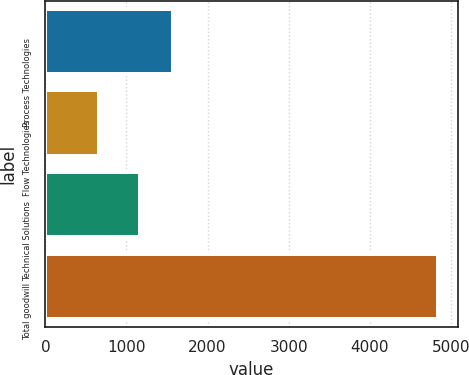<chart> <loc_0><loc_0><loc_500><loc_500><bar_chart><fcel>Process Technologies<fcel>Flow Technologies<fcel>Technical Solutions<fcel>Total goodwill<nl><fcel>1579.07<fcel>663.8<fcel>1161.7<fcel>4837.5<nl></chart> 